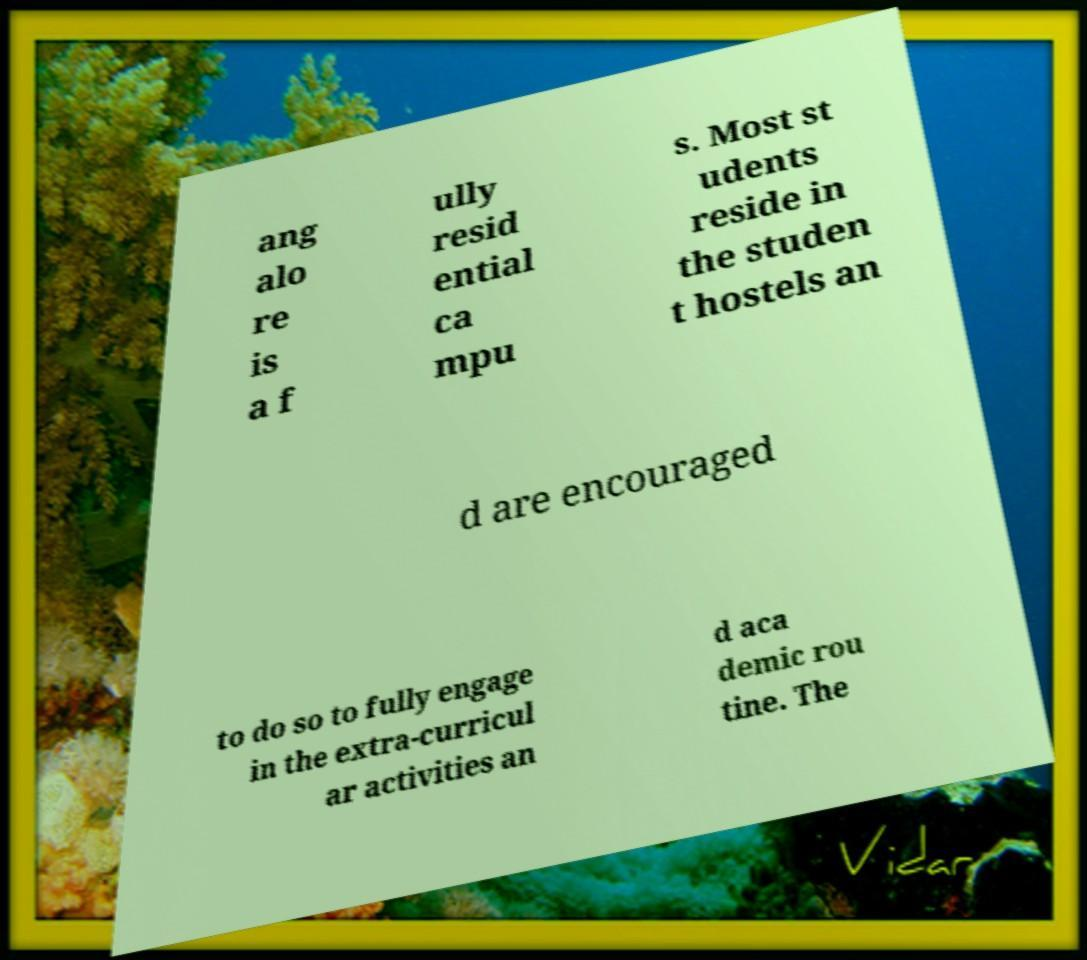There's text embedded in this image that I need extracted. Can you transcribe it verbatim? ang alo re is a f ully resid ential ca mpu s. Most st udents reside in the studen t hostels an d are encouraged to do so to fully engage in the extra-curricul ar activities an d aca demic rou tine. The 